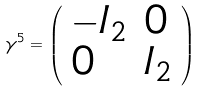<formula> <loc_0><loc_0><loc_500><loc_500>\gamma ^ { 5 } = { \left ( \begin{array} { l l } { - I _ { 2 } } & { 0 } \\ { 0 } & { I _ { 2 } } \end{array} \right ) }</formula> 